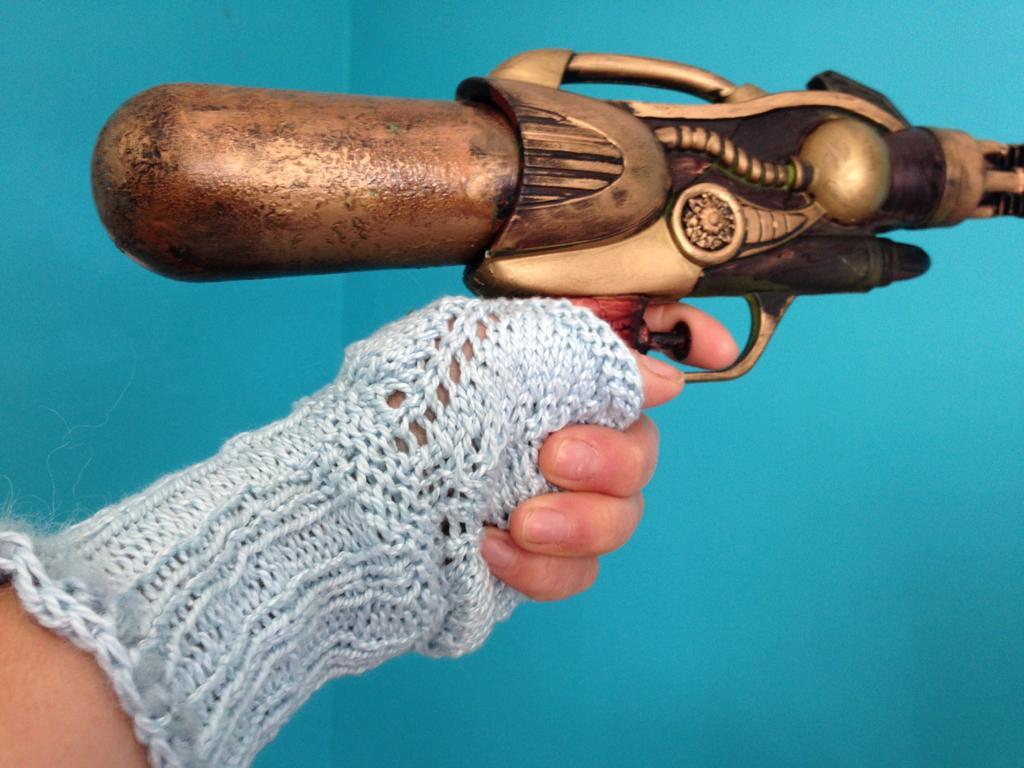How would you summarize this image in a sentence or two? In this picture there is a gun in the center of the image and there is a girl who is standing on the left side of the image. 